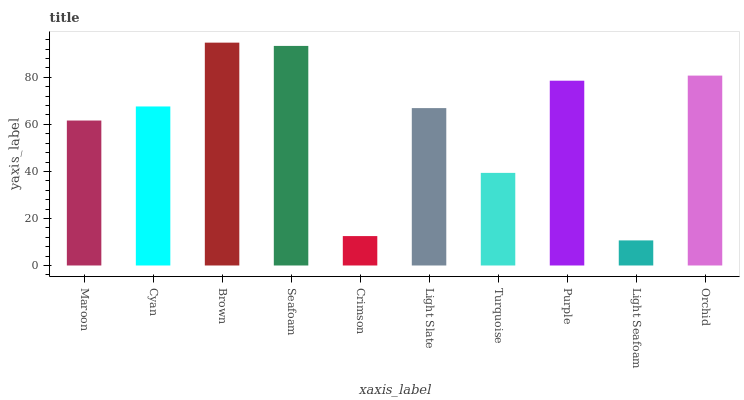Is Cyan the minimum?
Answer yes or no. No. Is Cyan the maximum?
Answer yes or no. No. Is Cyan greater than Maroon?
Answer yes or no. Yes. Is Maroon less than Cyan?
Answer yes or no. Yes. Is Maroon greater than Cyan?
Answer yes or no. No. Is Cyan less than Maroon?
Answer yes or no. No. Is Cyan the high median?
Answer yes or no. Yes. Is Light Slate the low median?
Answer yes or no. Yes. Is Turquoise the high median?
Answer yes or no. No. Is Cyan the low median?
Answer yes or no. No. 